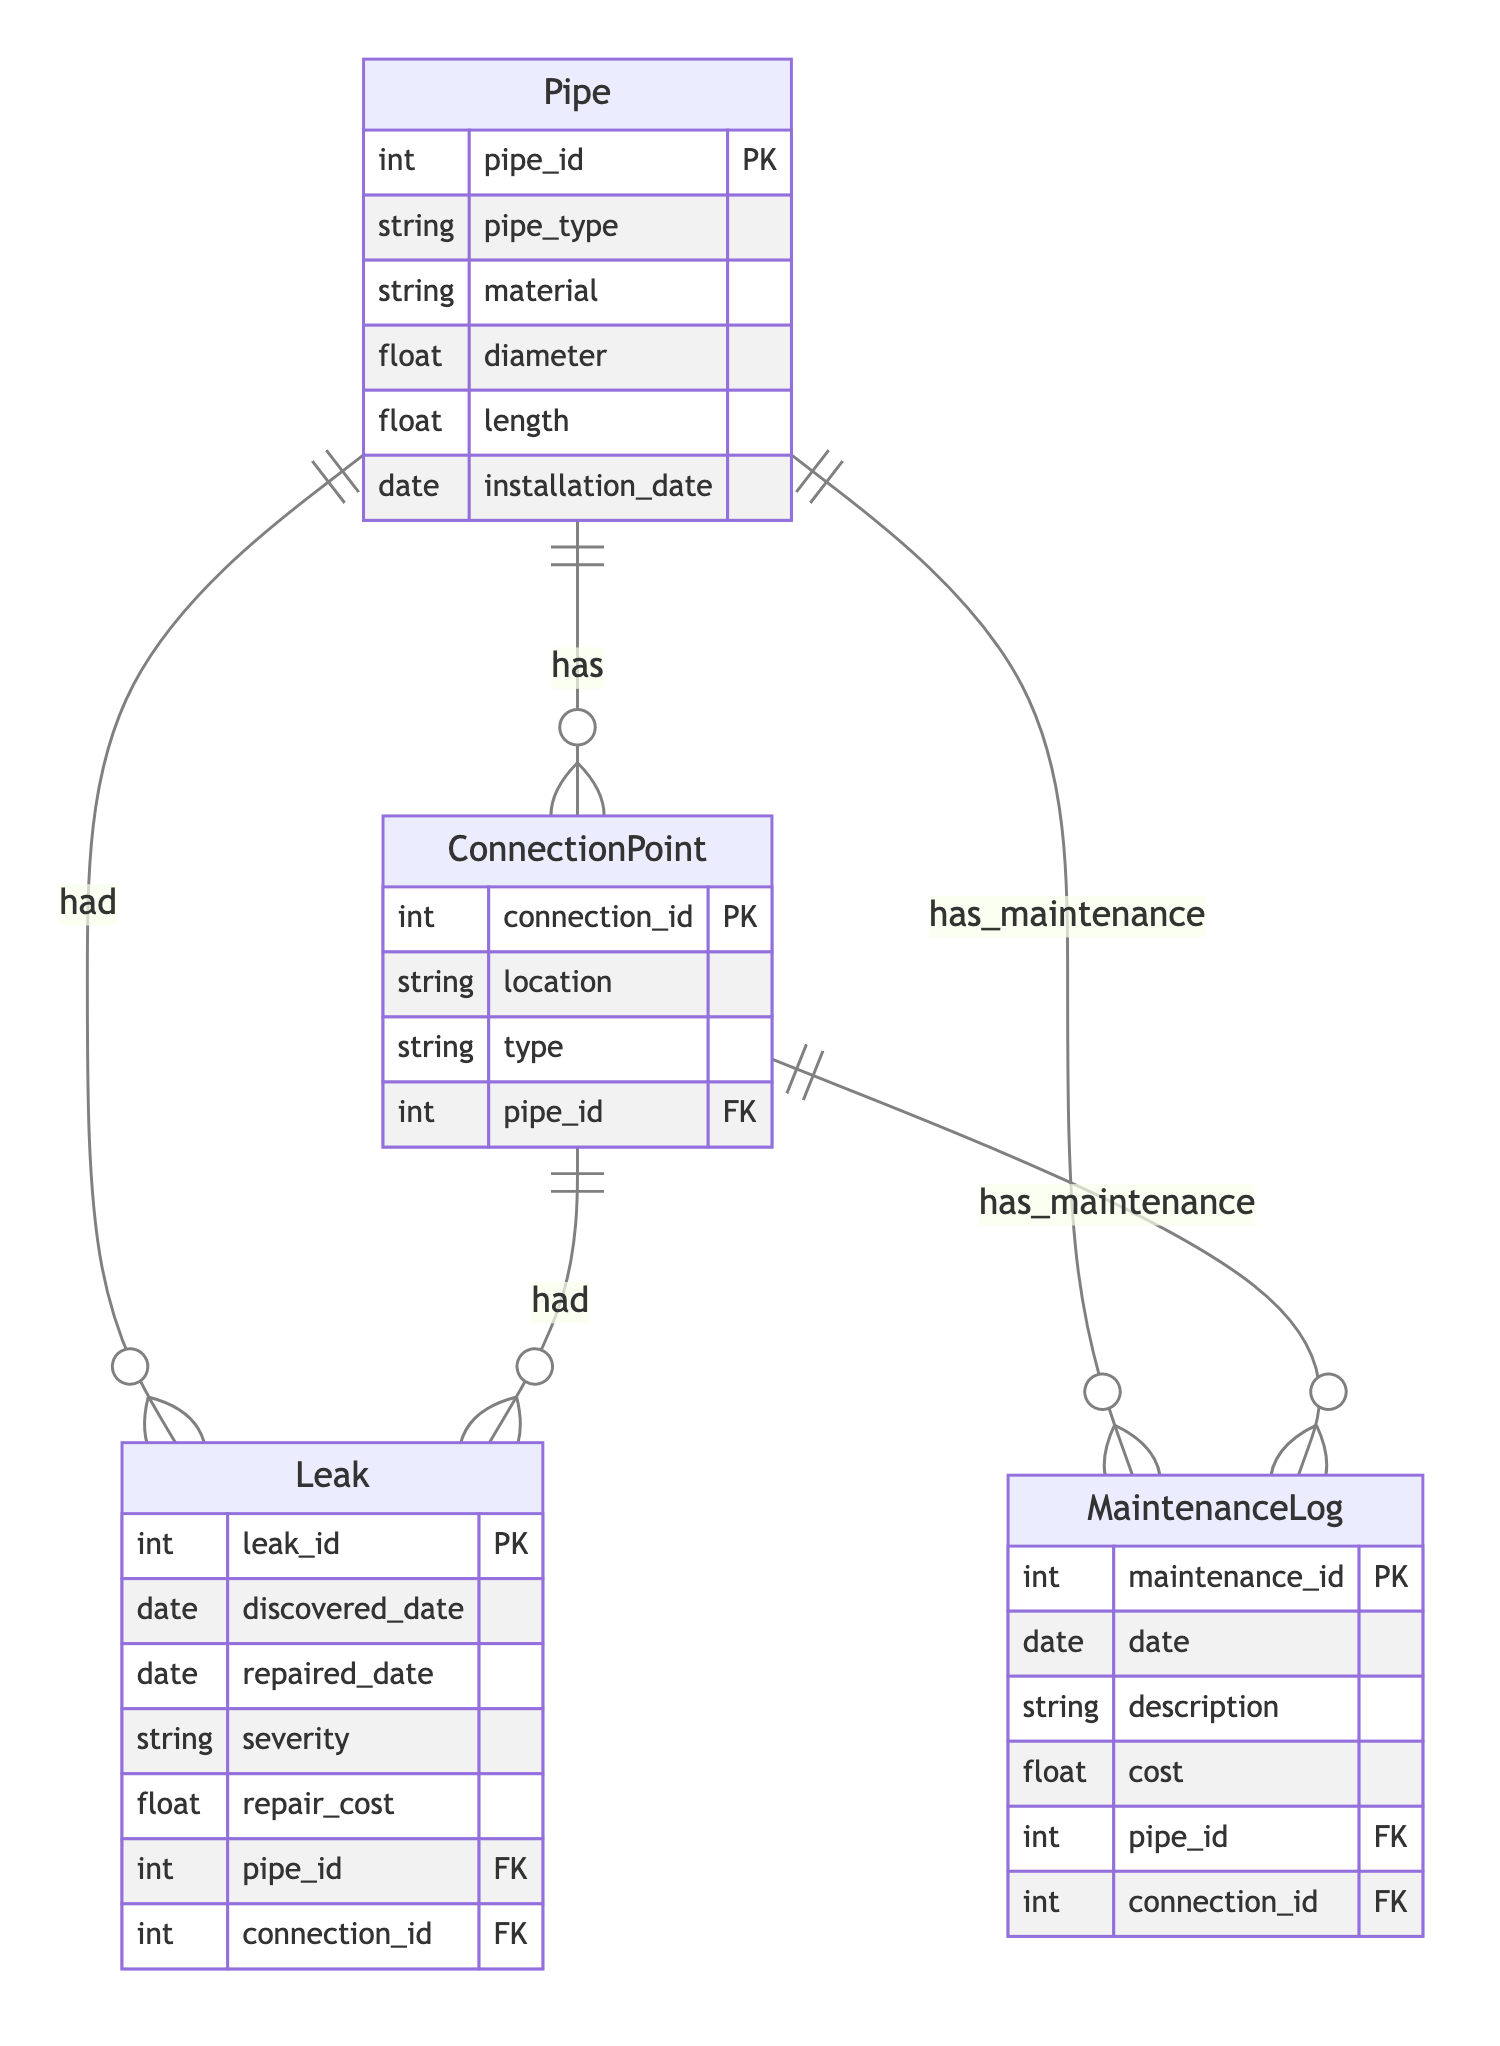What is the primary relationship between Pipe and ConnectionPoint? The diagram indicates that the primary relationship between Pipe and ConnectionPoint is "has." This means each Pipe can have multiple ConnectionPoints associated with it.
Answer: has How many attributes are in the Leak entity? The Leak entity contains six attributes including leak_id, discovered_date, repaired_date, severity, repair_cost, and pipe_id, connection_id. Counting these gives a total of six.
Answer: six What type of relationship exists between ConnectionPoint and Leak? The diagram shows that the relationship between ConnectionPoint and Leak is "had." This indicates that ConnectionPoints can have leaks associated with them, highlighting a historical relationship.
Answer: had How many entities are present in this diagram? The diagram includes four entities: Pipe, ConnectionPoint, Leak, and MaintenanceLog. Therefore, the total count of entities is four.
Answer: four What attribute is unique for the MaintenanceLog entity? The unique attribute for the MaintenanceLog entity is maintenance_id, which serves as the primary key for distinguishing different maintenance logs in the system.
Answer: maintenance_id Which entity has the most relationships in the diagram? By examining the relationships, the Pipe entity has the most connections, as it relates to ConnectionPoint, Leak, and MaintenanceLog, making it the central entity in this system.
Answer: Pipe What is the maximum number of leaks associated with a single pipe? The diagram indicates that a Pipe can have multiple associated Leaks. Since there is no specific limit mentioned, in theory, a single pipe can have many leaks over its lifespan.
Answer: many How many types of entities have a maintenance relationship? Both Pipe and ConnectionPoint entities have a maintenance relationship with MaintenanceLog, resulting in a total of two entity types maintaining logs.
Answer: two What is the data type of the diameter attribute in the Pipe entity? The data type of the diameter attribute is specified as "float," indicating it can hold decimal values for more precise measurements.
Answer: float 